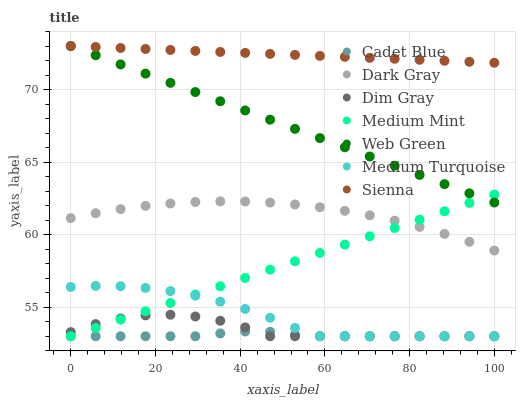Does Cadet Blue have the minimum area under the curve?
Answer yes or no. Yes. Does Sienna have the maximum area under the curve?
Answer yes or no. Yes. Does Dim Gray have the minimum area under the curve?
Answer yes or no. No. Does Dim Gray have the maximum area under the curve?
Answer yes or no. No. Is Medium Mint the smoothest?
Answer yes or no. Yes. Is Dim Gray the roughest?
Answer yes or no. Yes. Is Sienna the smoothest?
Answer yes or no. No. Is Sienna the roughest?
Answer yes or no. No. Does Medium Mint have the lowest value?
Answer yes or no. Yes. Does Sienna have the lowest value?
Answer yes or no. No. Does Web Green have the highest value?
Answer yes or no. Yes. Does Dim Gray have the highest value?
Answer yes or no. No. Is Medium Turquoise less than Sienna?
Answer yes or no. Yes. Is Sienna greater than Dim Gray?
Answer yes or no. Yes. Does Dim Gray intersect Medium Mint?
Answer yes or no. Yes. Is Dim Gray less than Medium Mint?
Answer yes or no. No. Is Dim Gray greater than Medium Mint?
Answer yes or no. No. Does Medium Turquoise intersect Sienna?
Answer yes or no. No. 